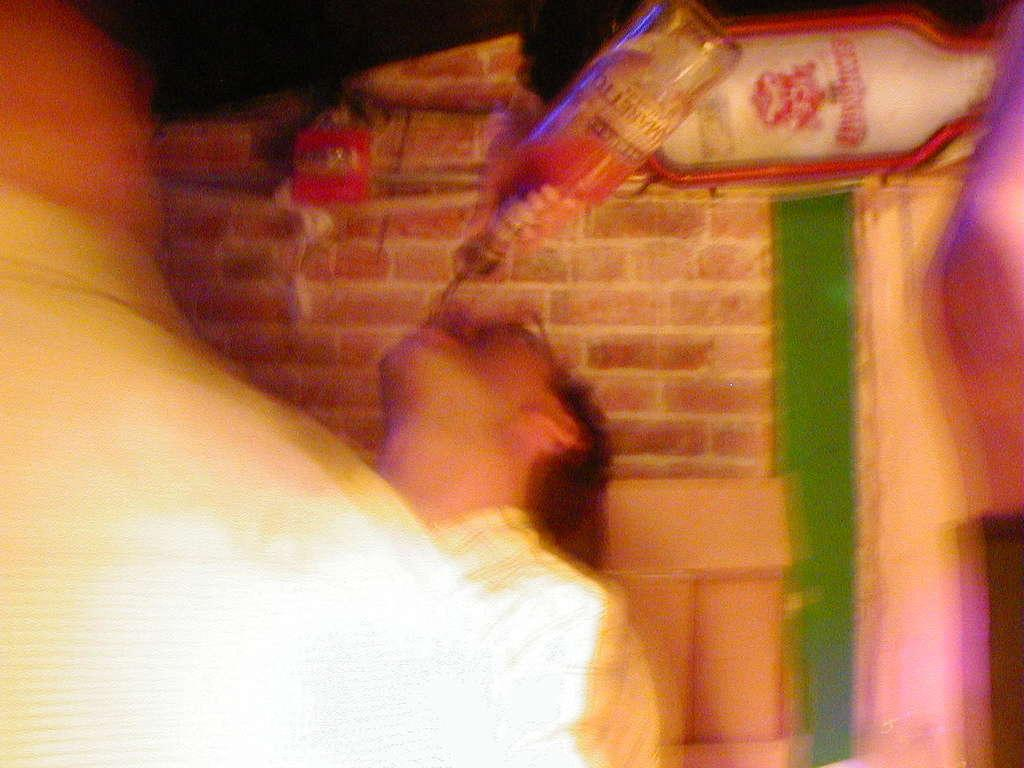What is happening in the image? There is a person in the image who is drinking liquid from a bottle. How is the person holding the bottle? The bottle appears to be in the air, suggesting that the person is holding it up. What can be seen in the background of the image? There is a wall in the background of the image. What type of badge is the owl wearing in the image? There is no owl or badge present in the image. How many legs does the person have in the image? The person in the image has two legs, but this question is unnecessary as the number of legs is not relevant to the image's content. 